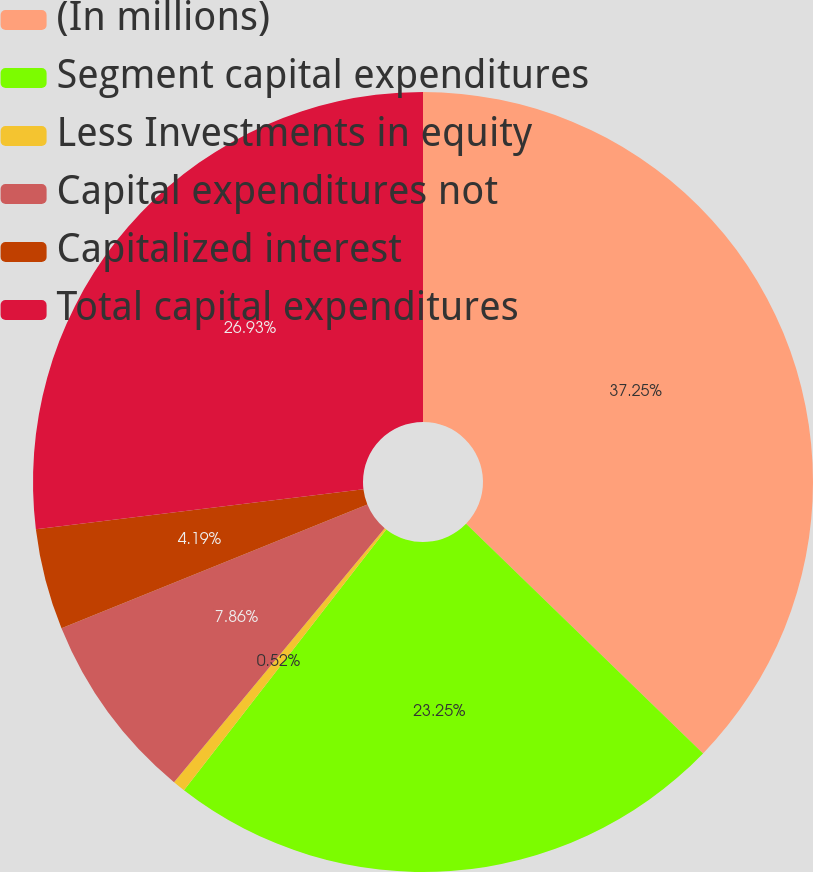Convert chart. <chart><loc_0><loc_0><loc_500><loc_500><pie_chart><fcel>(In millions)<fcel>Segment capital expenditures<fcel>Less Investments in equity<fcel>Capital expenditures not<fcel>Capitalized interest<fcel>Total capital expenditures<nl><fcel>37.25%<fcel>23.25%<fcel>0.52%<fcel>7.86%<fcel>4.19%<fcel>26.93%<nl></chart> 